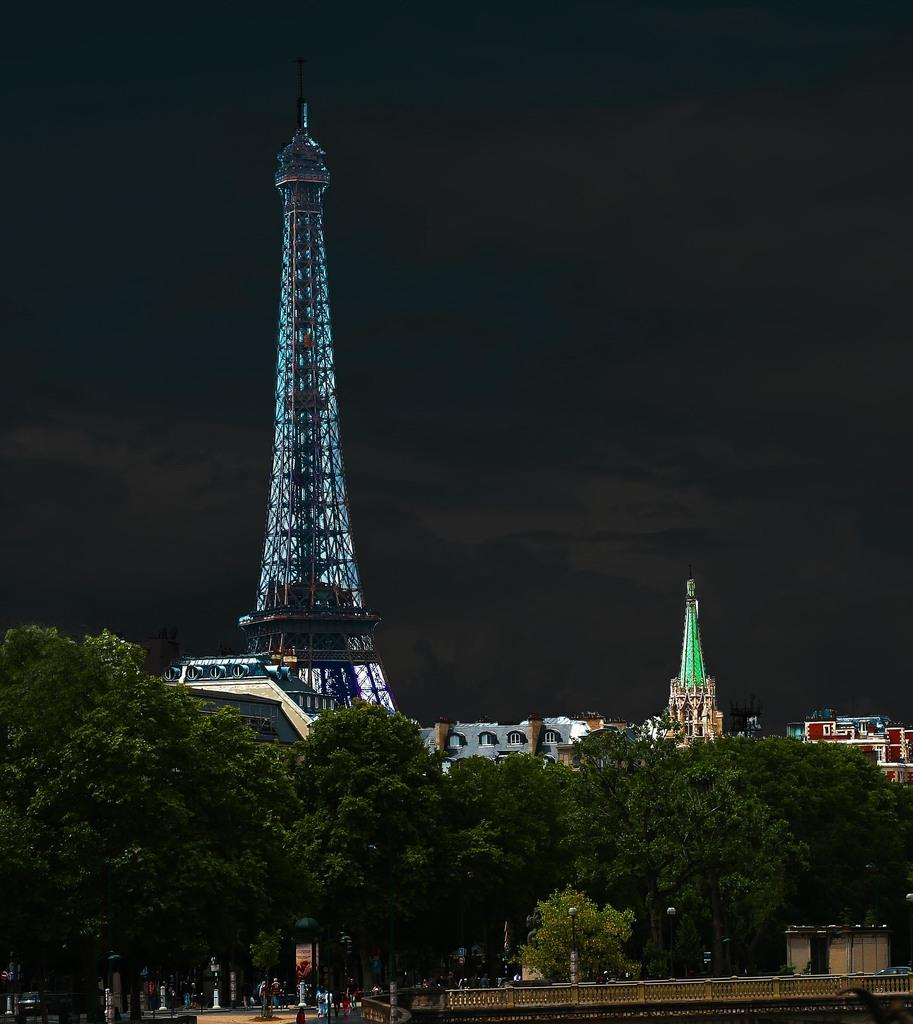How many people are in the image? There are few persons in the image. What type of natural elements can be seen in the image? There are trees in the image. What type of man-made structures are visible in the image? There is a hoarding, buildings, and towers in the image. What is visible in the background of the image? The sky is visible in the background of the image. What type of fear is depicted in the image? There is no fear depicted in the image; it features people, trees, a hoarding, buildings, towers, and the sky. What season is represented by the spring in the image? There is no mention of spring or any season in the image; it only shows the sky in the background. 